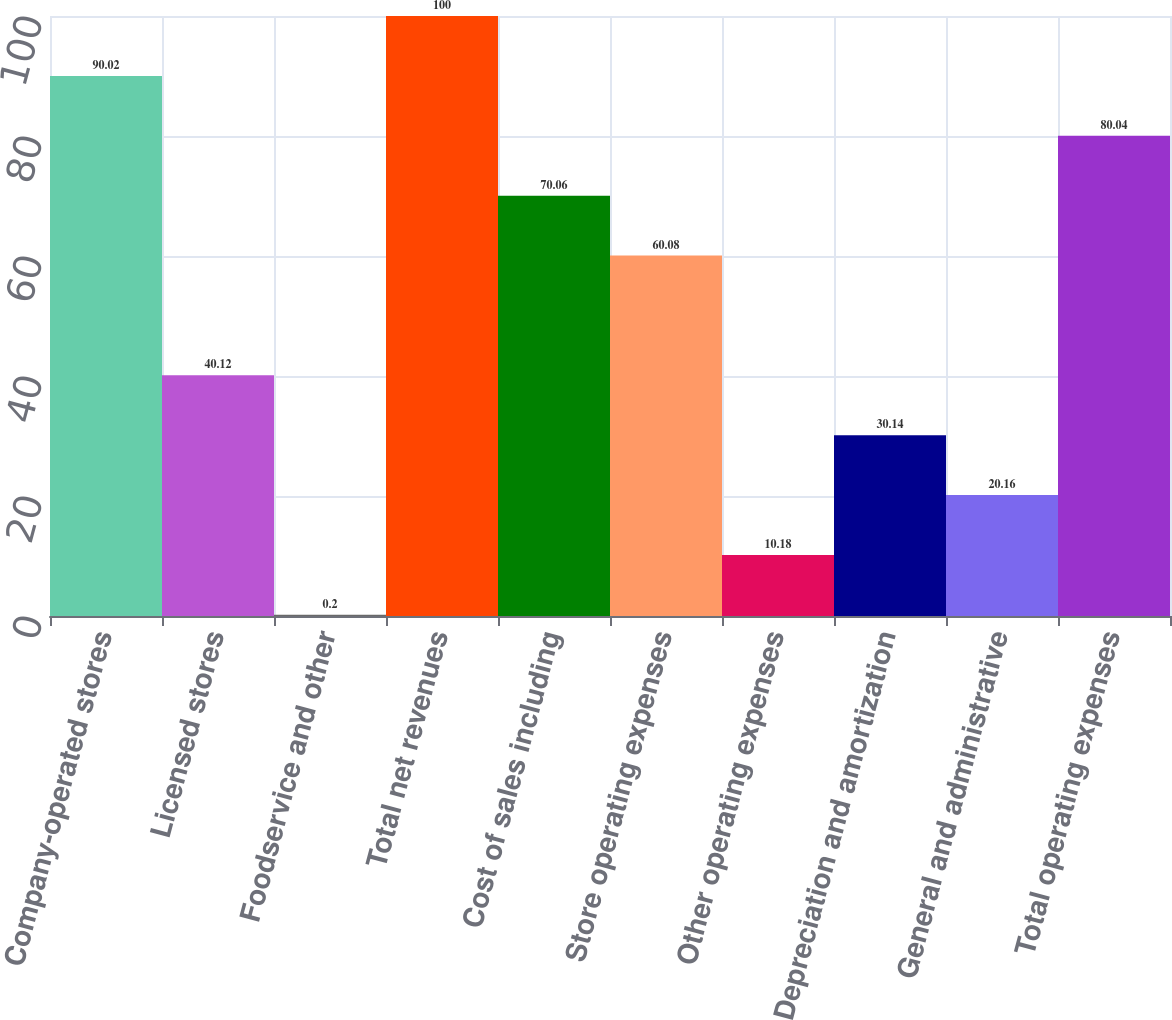Convert chart. <chart><loc_0><loc_0><loc_500><loc_500><bar_chart><fcel>Company-operated stores<fcel>Licensed stores<fcel>Foodservice and other<fcel>Total net revenues<fcel>Cost of sales including<fcel>Store operating expenses<fcel>Other operating expenses<fcel>Depreciation and amortization<fcel>General and administrative<fcel>Total operating expenses<nl><fcel>90.02<fcel>40.12<fcel>0.2<fcel>100<fcel>70.06<fcel>60.08<fcel>10.18<fcel>30.14<fcel>20.16<fcel>80.04<nl></chart> 